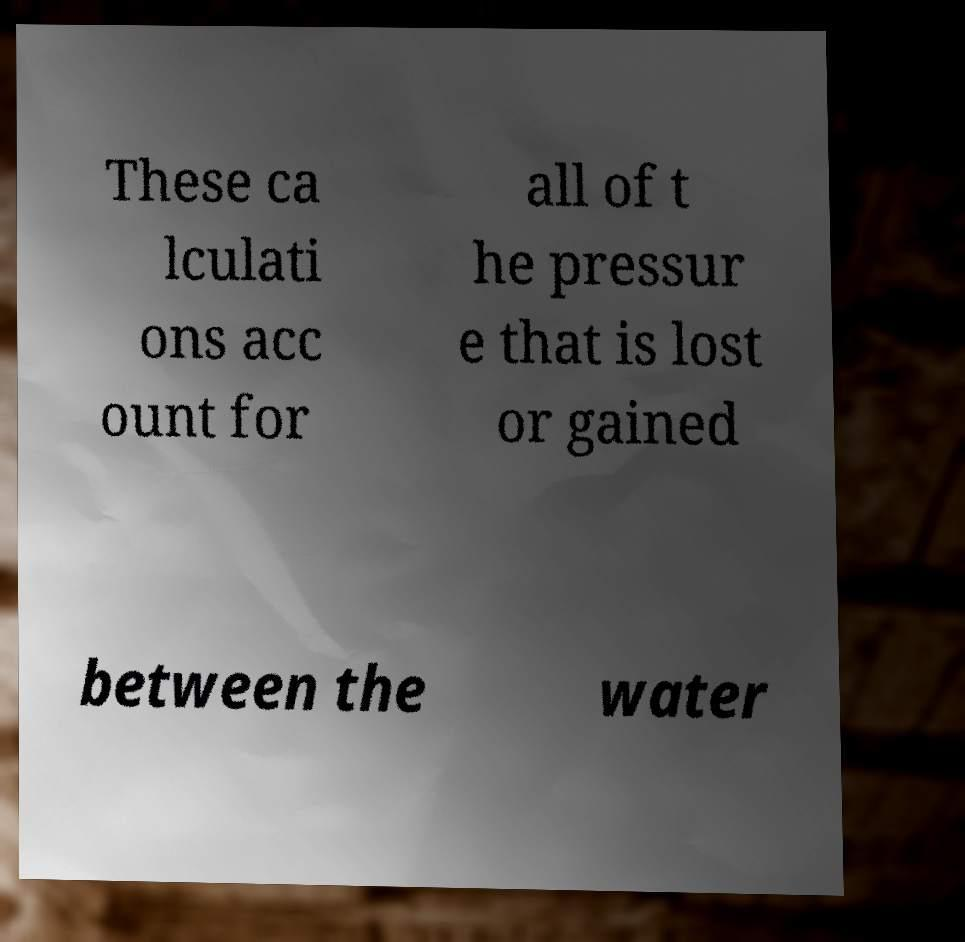What messages or text are displayed in this image? I need them in a readable, typed format. These ca lculati ons acc ount for all of t he pressur e that is lost or gained between the water 